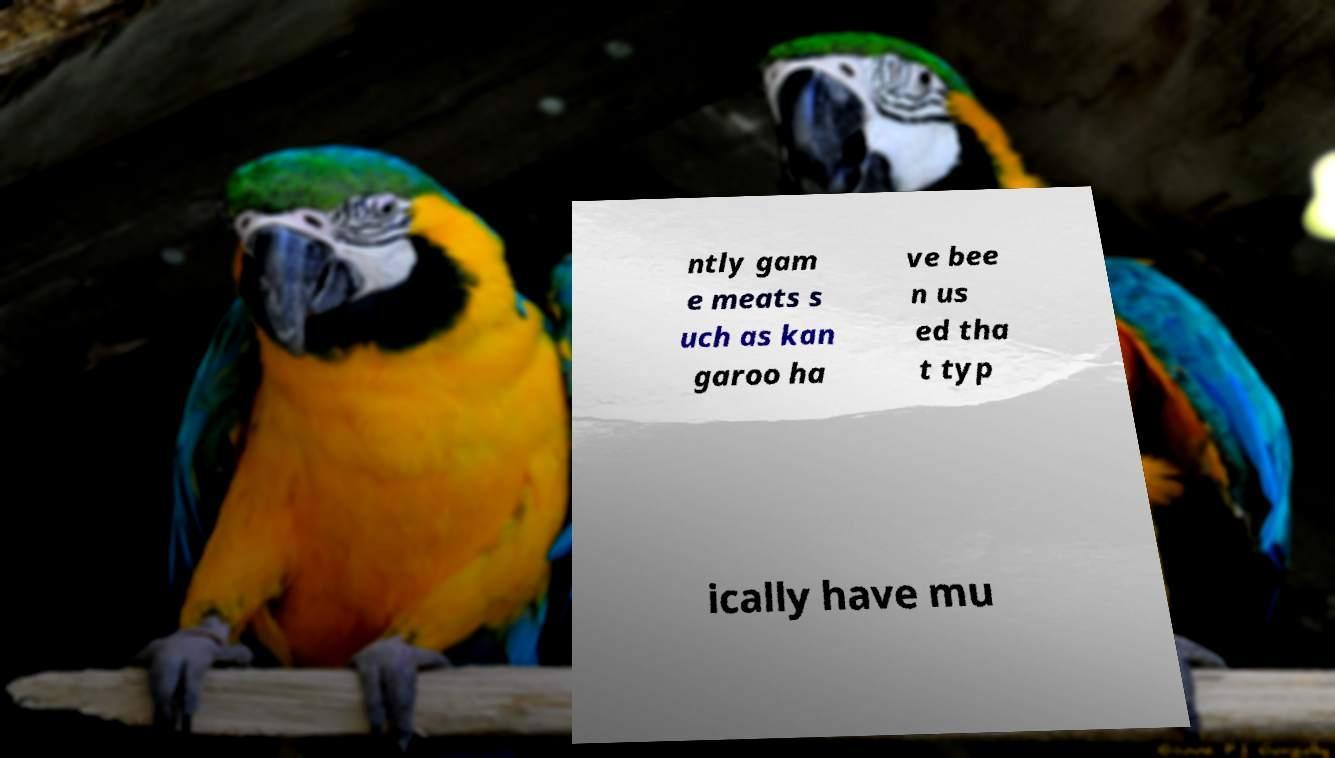Please read and relay the text visible in this image. What does it say? ntly gam e meats s uch as kan garoo ha ve bee n us ed tha t typ ically have mu 